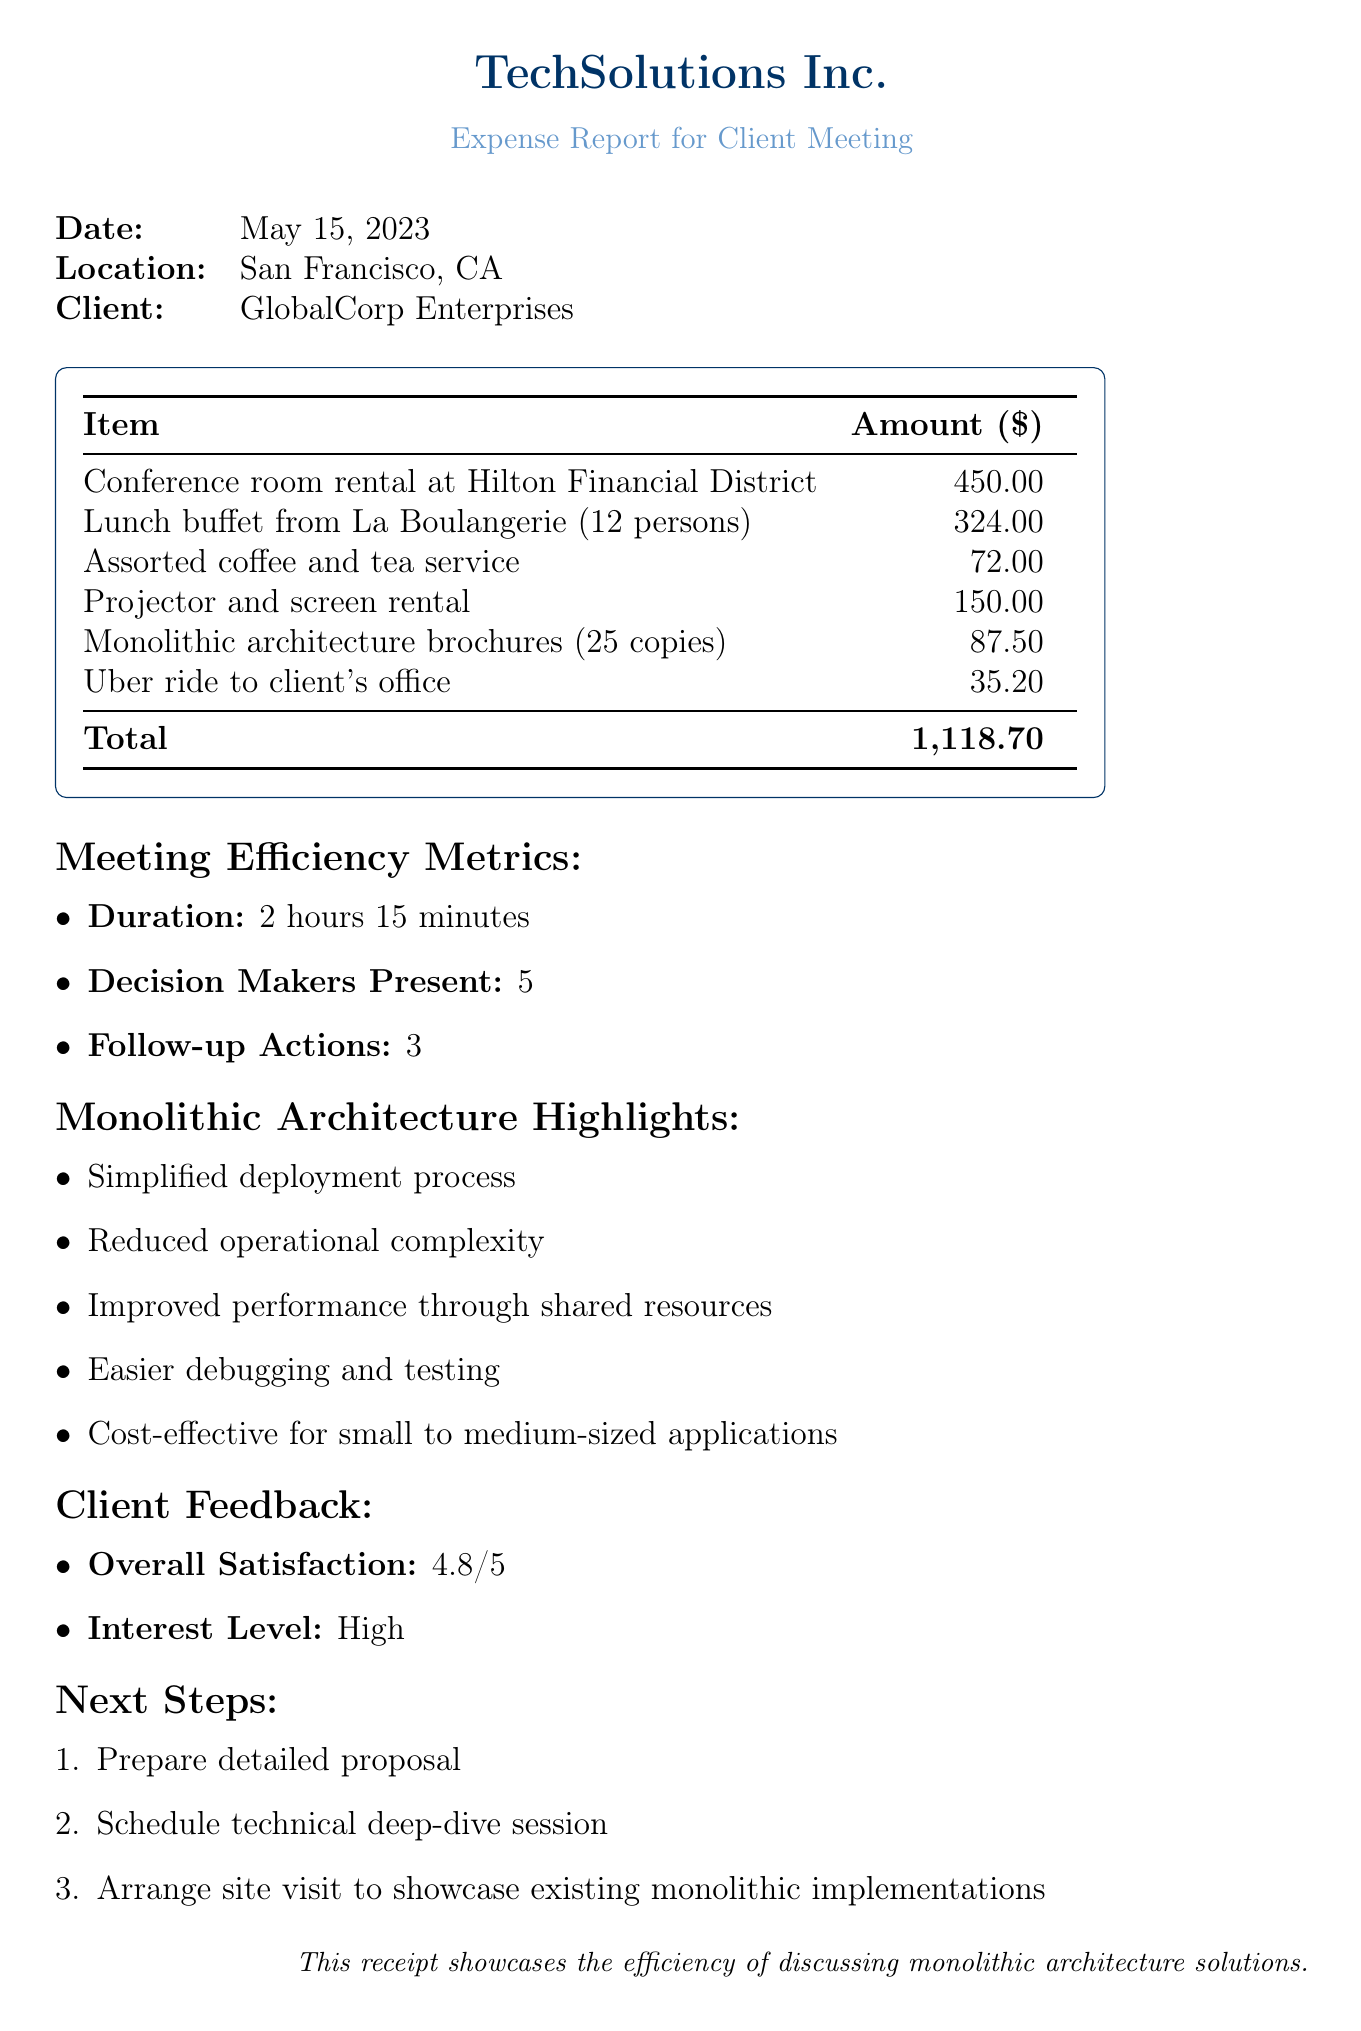What is the company name? The company name is listed at the top of the document in the header section.
Answer: TechSolutions Inc What is the total expense? The total expenses are calculated and presented in the summary table at the end of the meeting expense section.
Answer: 1,118.70 What was the meeting duration? The duration of the meeting is specified in the meeting efficiency metrics section.
Answer: 2 hours 15 minutes How many decision makers were present? The number of decision makers is found in the meeting efficiency metrics section after the duration.
Answer: 5 What was the overall client satisfaction rating? The overall satisfaction rating is provided in the client feedback section of the document.
Answer: 4.8 What was the location of the meeting? The location is mentioned alongside the date and client name at the top of the document.
Answer: San Francisco, CA What is one key concern addressed during the meeting? The key concerns addressed are listed in the client feedback section.
Answer: Long-term scalability How many brochures about monolithic architecture were printed? The quantity of printed materials is given within the meeting expenses section focused on printed materials.
Answer: 25 copies What is one highlight of monolithic architecture mentioned? The highlights are detailed in a specific section about monolithic architecture in the document.
Answer: Simplified deployment process 